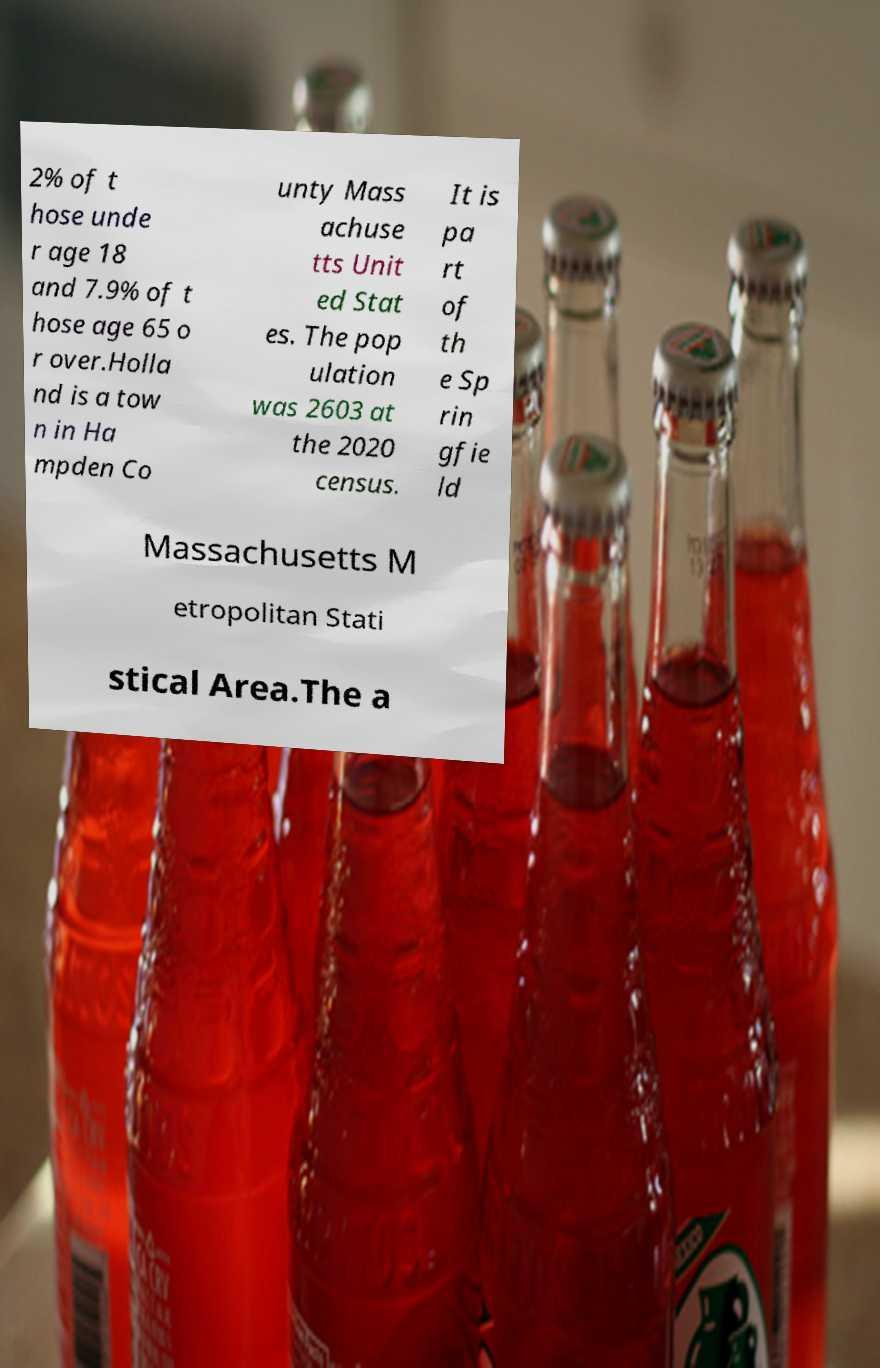Could you extract and type out the text from this image? 2% of t hose unde r age 18 and 7.9% of t hose age 65 o r over.Holla nd is a tow n in Ha mpden Co unty Mass achuse tts Unit ed Stat es. The pop ulation was 2603 at the 2020 census. It is pa rt of th e Sp rin gfie ld Massachusetts M etropolitan Stati stical Area.The a 